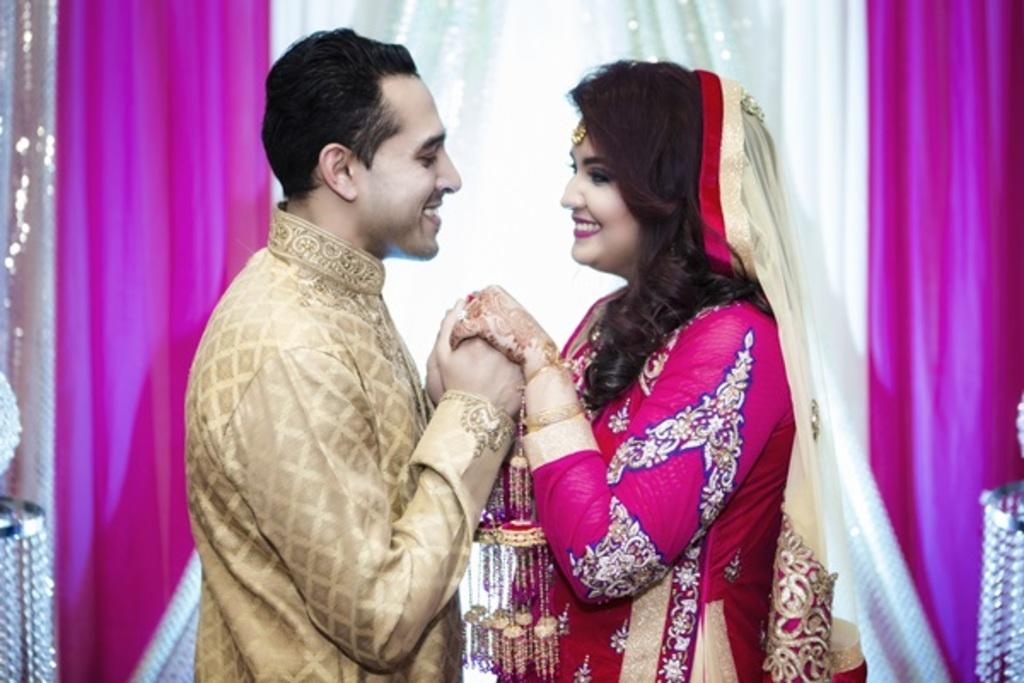Who is present in the image? There is a man and a woman in the image. What are the man and woman doing in the image? The man and woman are holding hands. What can be seen in the background of the image? There are clothes visible in the background of the image. How many eggs are visible in the image? There are no eggs present in the image. What type of insect can be seen on the woman's shoulder in the image? There is no insect visible on the woman's shoulder in the image. 